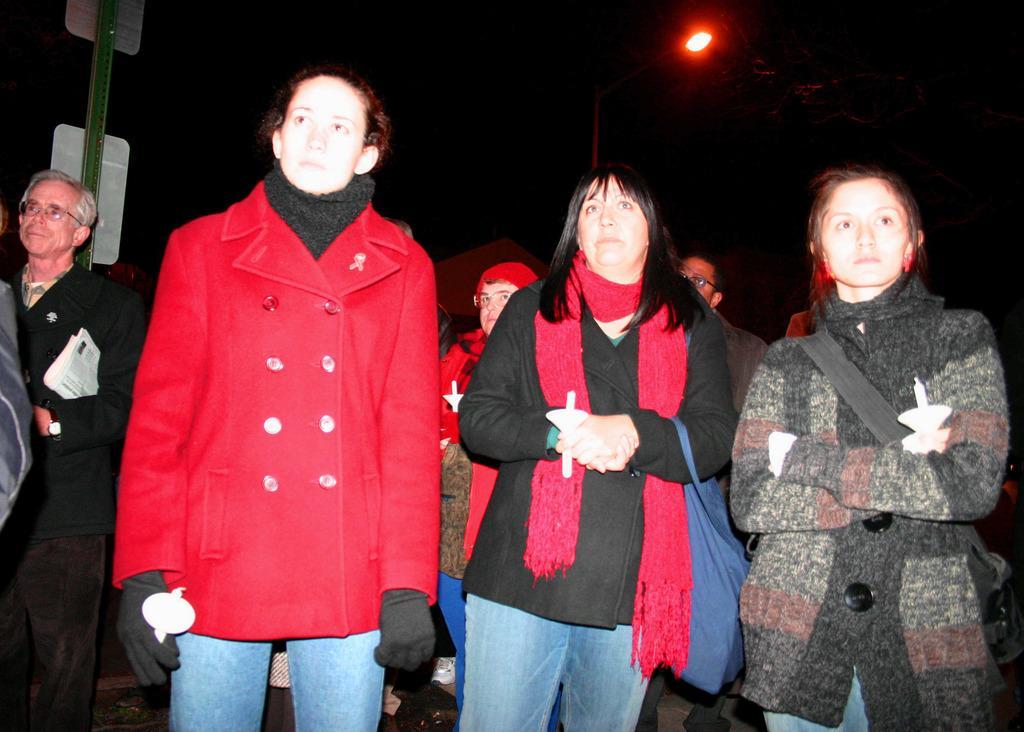Could you give a brief overview of what you see in this image? In this image we can see a group of persons and there are holding objects. In the top left, we can see a pole with boards. At the top we can see the light. The background of the image is dark. 